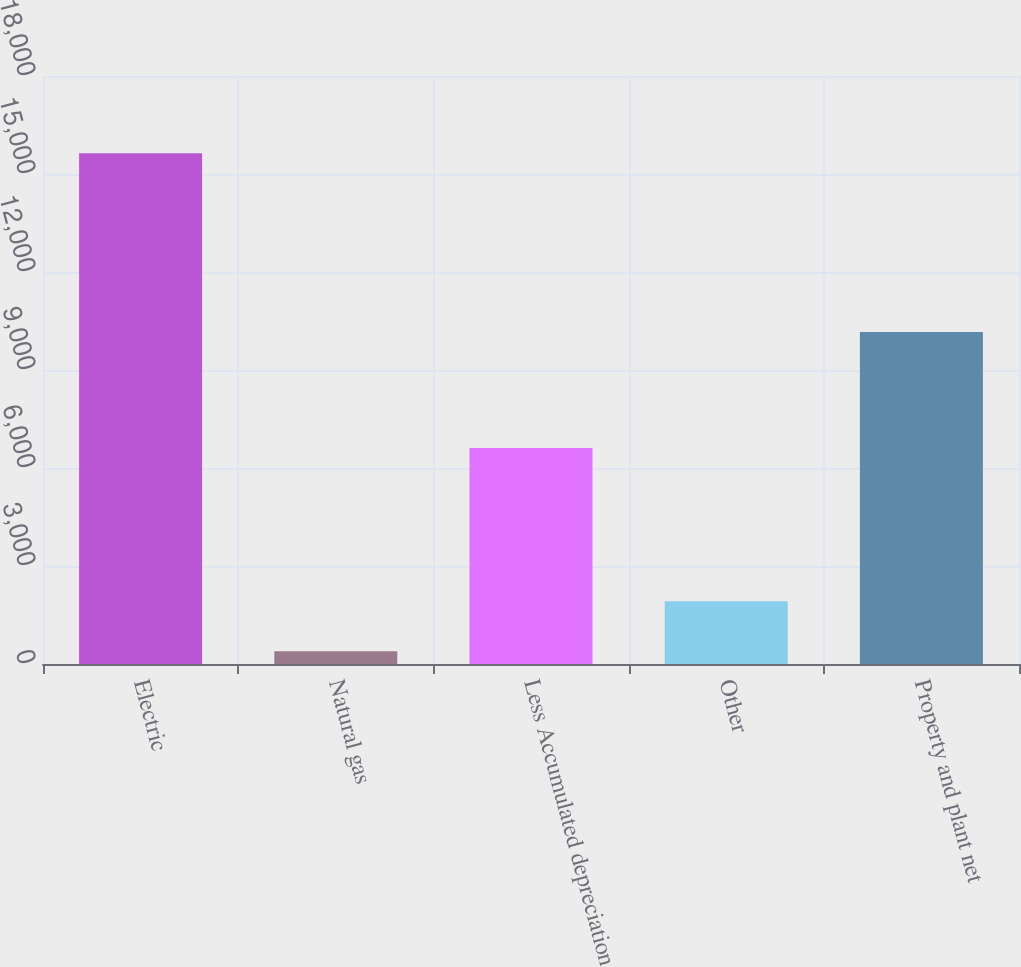<chart> <loc_0><loc_0><loc_500><loc_500><bar_chart><fcel>Electric<fcel>Natural gas<fcel>Less Accumulated depreciation<fcel>Other<fcel>Property and plant net<nl><fcel>15638<fcel>393<fcel>6614<fcel>1917.5<fcel>10161<nl></chart> 